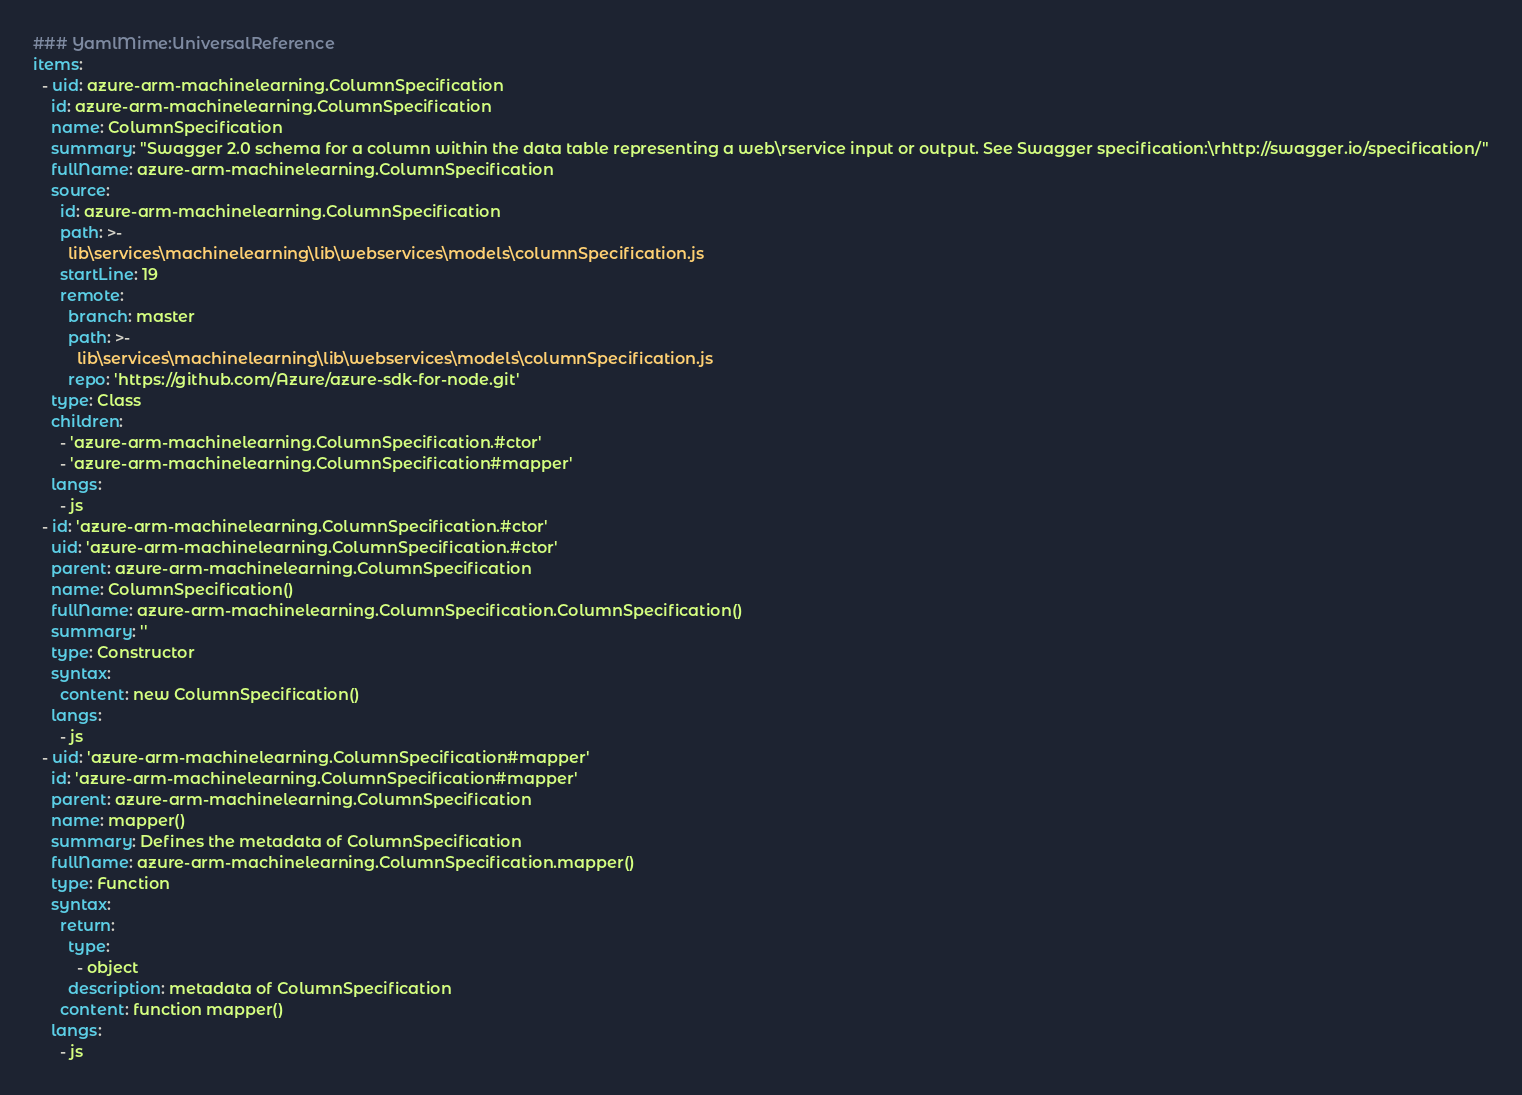<code> <loc_0><loc_0><loc_500><loc_500><_YAML_>### YamlMime:UniversalReference
items:
  - uid: azure-arm-machinelearning.ColumnSpecification
    id: azure-arm-machinelearning.ColumnSpecification
    name: ColumnSpecification
    summary: "Swagger 2.0 schema for a column within the data table representing a web\rservice input or output. See Swagger specification:\rhttp://swagger.io/specification/"
    fullName: azure-arm-machinelearning.ColumnSpecification
    source:
      id: azure-arm-machinelearning.ColumnSpecification
      path: >-
        lib\services\machinelearning\lib\webservices\models\columnSpecification.js
      startLine: 19
      remote:
        branch: master
        path: >-
          lib\services\machinelearning\lib\webservices\models\columnSpecification.js
        repo: 'https://github.com/Azure/azure-sdk-for-node.git'
    type: Class
    children:
      - 'azure-arm-machinelearning.ColumnSpecification.#ctor'
      - 'azure-arm-machinelearning.ColumnSpecification#mapper'
    langs:
      - js
  - id: 'azure-arm-machinelearning.ColumnSpecification.#ctor'
    uid: 'azure-arm-machinelearning.ColumnSpecification.#ctor'
    parent: azure-arm-machinelearning.ColumnSpecification
    name: ColumnSpecification()
    fullName: azure-arm-machinelearning.ColumnSpecification.ColumnSpecification()
    summary: ''
    type: Constructor
    syntax:
      content: new ColumnSpecification()
    langs:
      - js
  - uid: 'azure-arm-machinelearning.ColumnSpecification#mapper'
    id: 'azure-arm-machinelearning.ColumnSpecification#mapper'
    parent: azure-arm-machinelearning.ColumnSpecification
    name: mapper()
    summary: Defines the metadata of ColumnSpecification
    fullName: azure-arm-machinelearning.ColumnSpecification.mapper()
    type: Function
    syntax:
      return:
        type:
          - object
        description: metadata of ColumnSpecification
      content: function mapper()
    langs:
      - js
</code> 